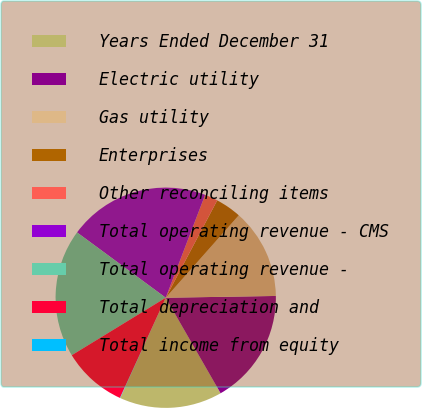Convert chart. <chart><loc_0><loc_0><loc_500><loc_500><pie_chart><fcel>Years Ended December 31<fcel>Electric utility<fcel>Gas utility<fcel>Enterprises<fcel>Other reconciling items<fcel>Total operating revenue - CMS<fcel>Total operating revenue -<fcel>Total depreciation and<fcel>Total income from equity<nl><fcel>15.08%<fcel>16.96%<fcel>13.2%<fcel>3.8%<fcel>1.92%<fcel>20.72%<fcel>18.84%<fcel>9.44%<fcel>0.04%<nl></chart> 